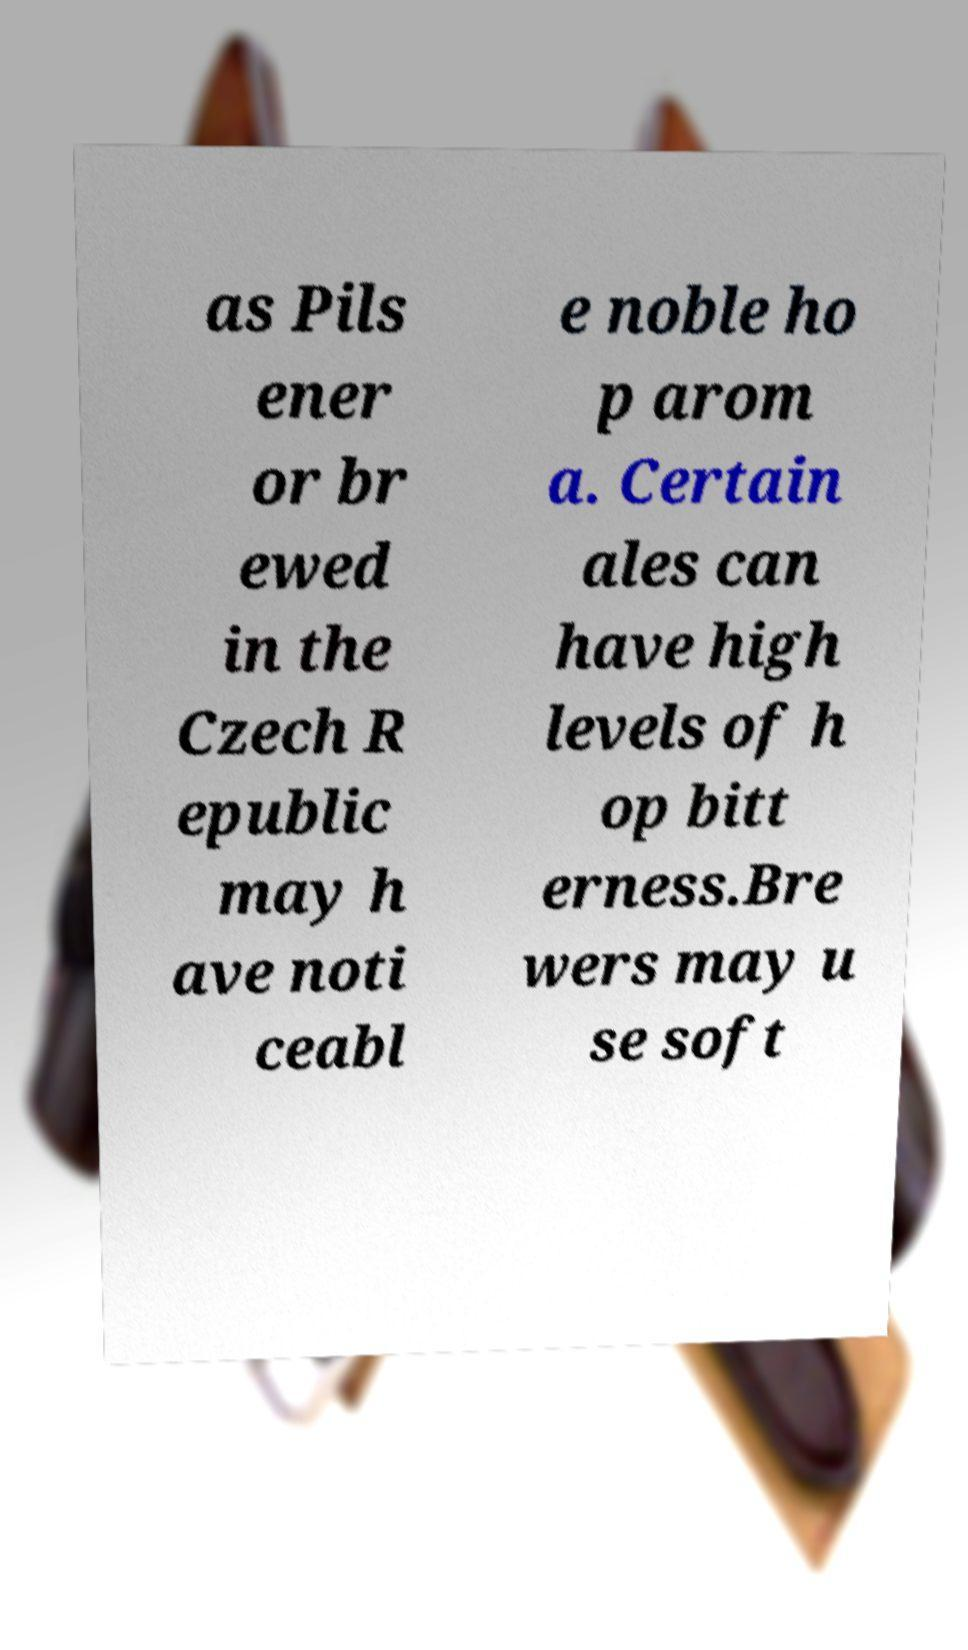I need the written content from this picture converted into text. Can you do that? as Pils ener or br ewed in the Czech R epublic may h ave noti ceabl e noble ho p arom a. Certain ales can have high levels of h op bitt erness.Bre wers may u se soft 